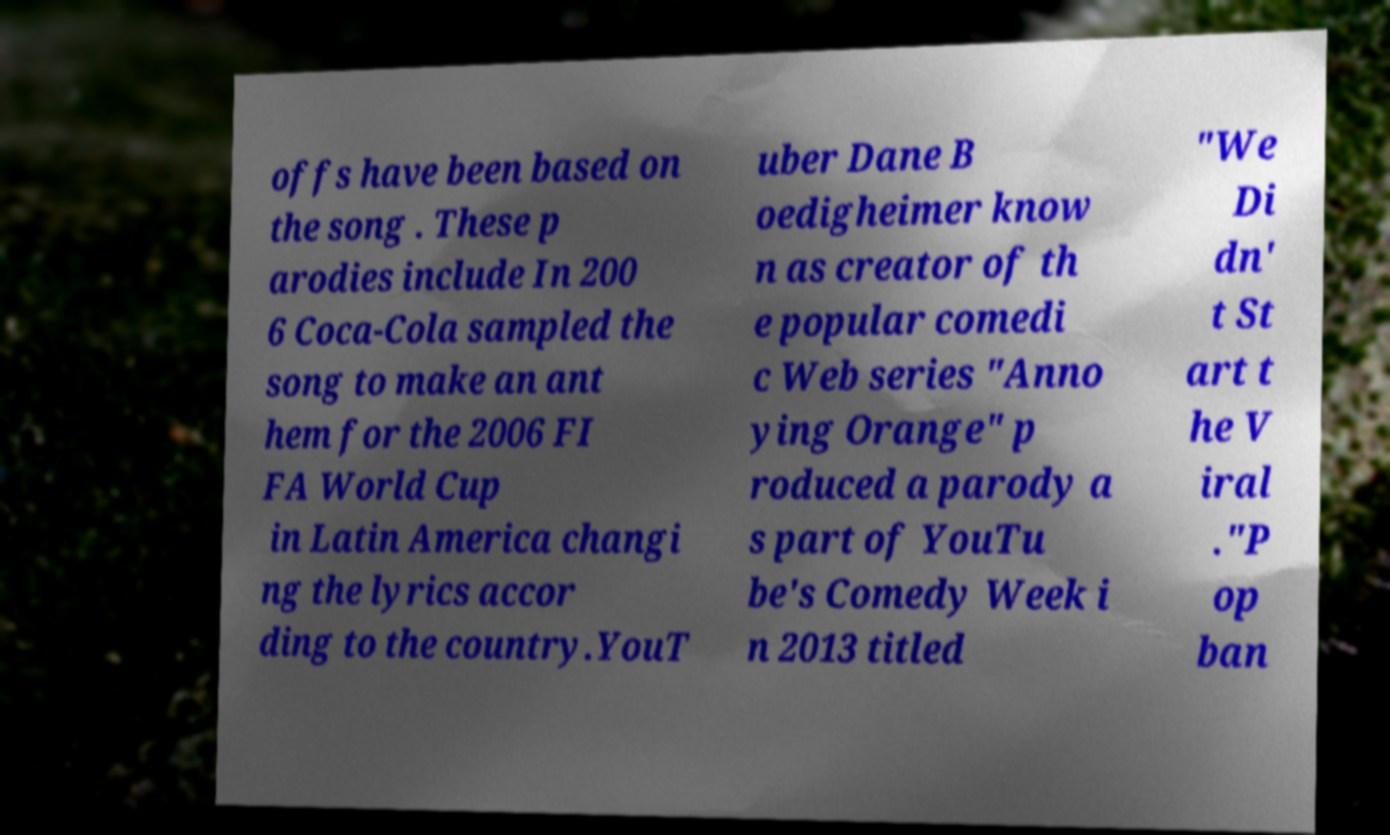Please read and relay the text visible in this image. What does it say? offs have been based on the song . These p arodies include In 200 6 Coca-Cola sampled the song to make an ant hem for the 2006 FI FA World Cup in Latin America changi ng the lyrics accor ding to the country.YouT uber Dane B oedigheimer know n as creator of th e popular comedi c Web series "Anno ying Orange" p roduced a parody a s part of YouTu be's Comedy Week i n 2013 titled "We Di dn' t St art t he V iral ."P op ban 